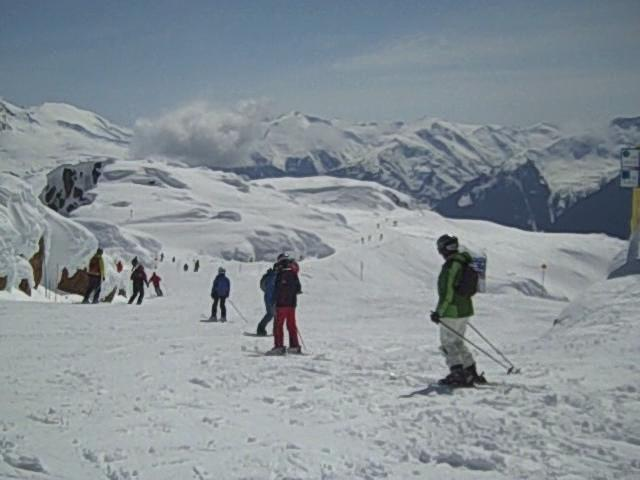What season brings this weather? winter 